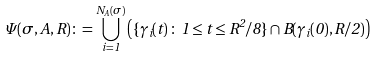Convert formula to latex. <formula><loc_0><loc_0><loc_500><loc_500>\Psi ( \sigma , A , R ) \colon = \bigcup _ { i = 1 } ^ { N _ { A } ( \sigma ) } \left ( \{ \gamma _ { i } ( t ) \, \colon \, 1 \leq t \leq R ^ { 2 } / 8 \} \cap B ( \gamma _ { i } ( 0 ) , R / 2 ) \right )</formula> 